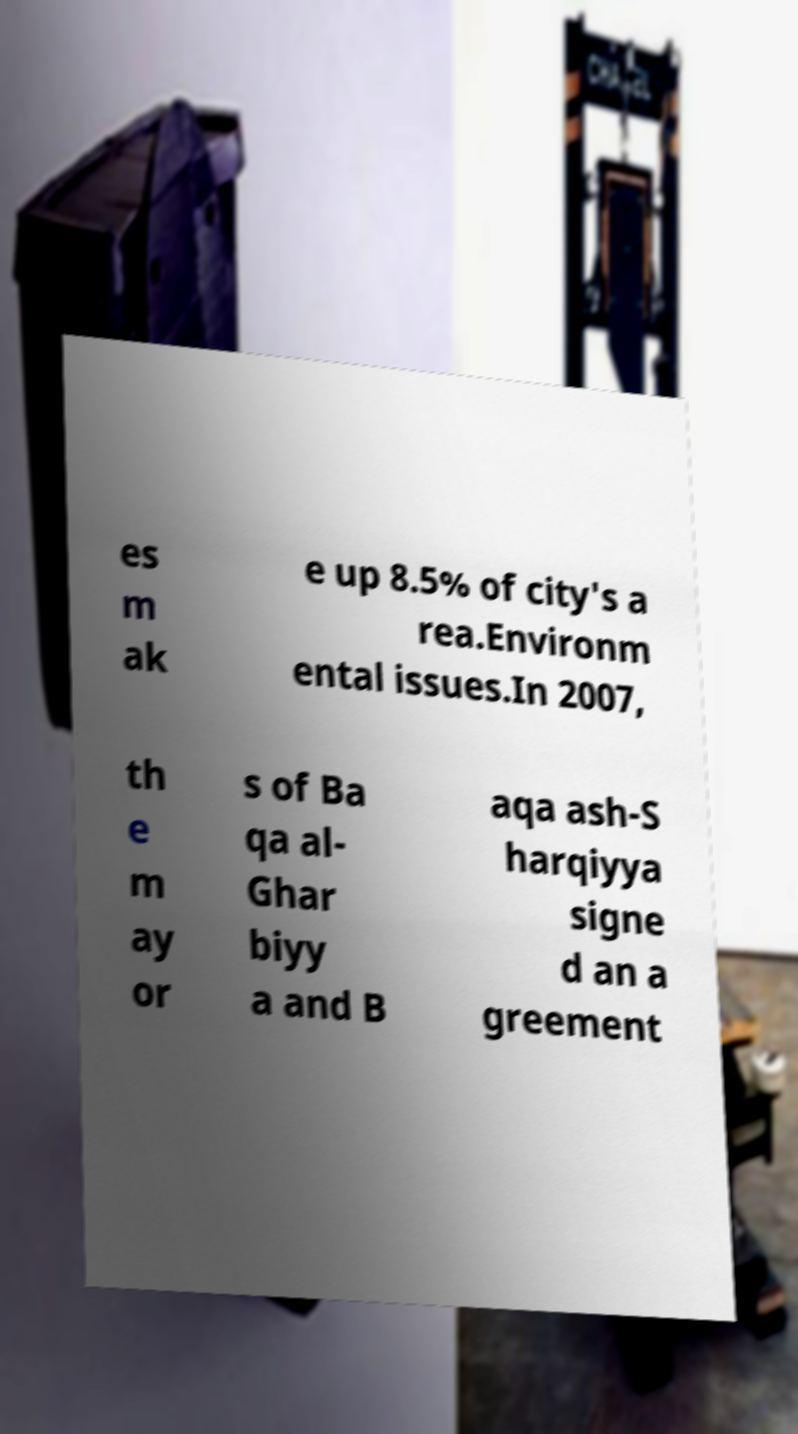There's text embedded in this image that I need extracted. Can you transcribe it verbatim? es m ak e up 8.5% of city's a rea.Environm ental issues.In 2007, th e m ay or s of Ba qa al- Ghar biyy a and B aqa ash-S harqiyya signe d an a greement 